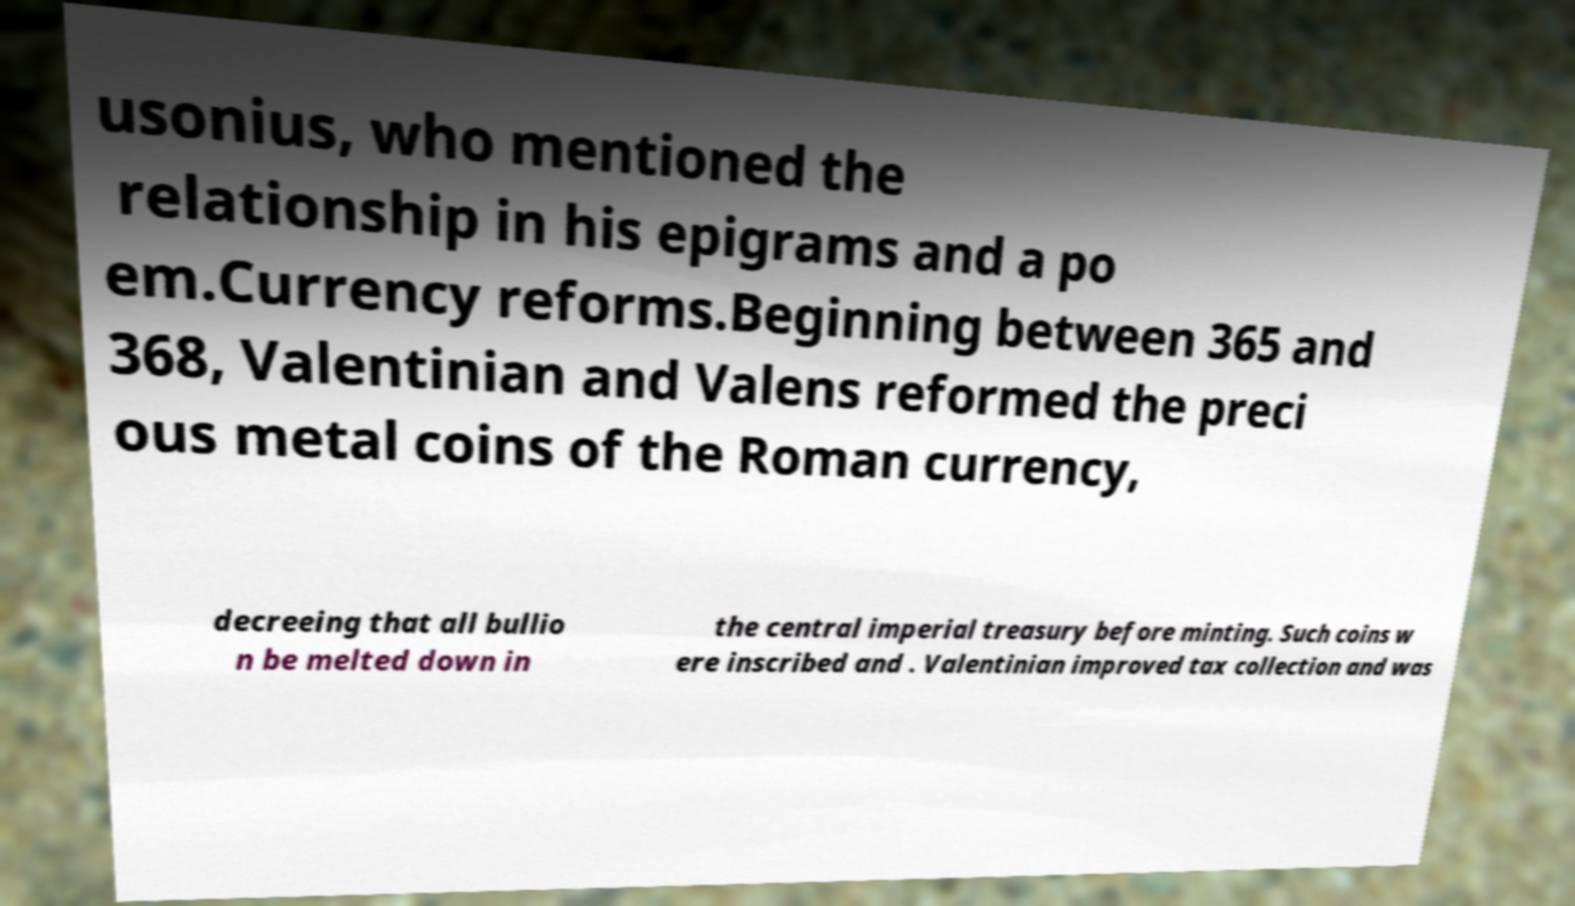Can you accurately transcribe the text from the provided image for me? usonius, who mentioned the relationship in his epigrams and a po em.Currency reforms.Beginning between 365 and 368, Valentinian and Valens reformed the preci ous metal coins of the Roman currency, decreeing that all bullio n be melted down in the central imperial treasury before minting. Such coins w ere inscribed and . Valentinian improved tax collection and was 